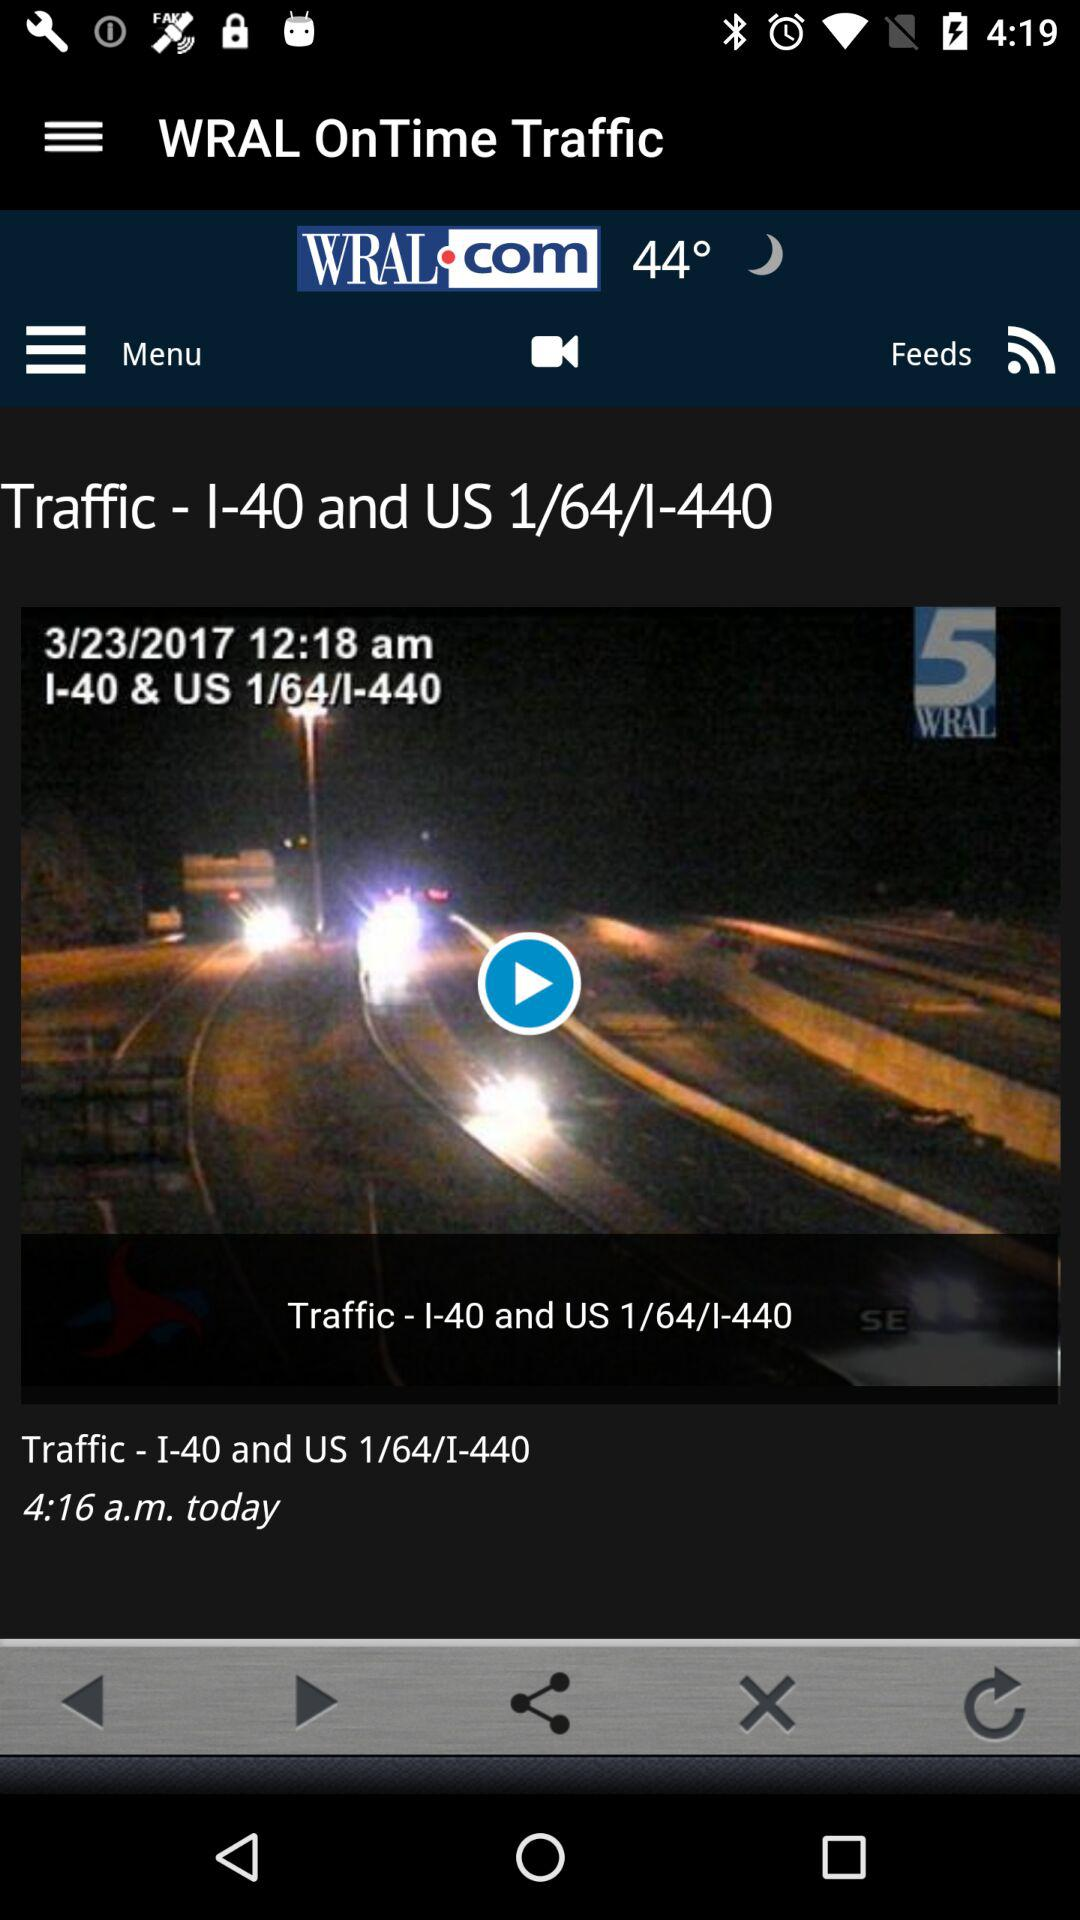What is the name of the television station that is broadcasting the video? The name of the television station that is broadcasting the video is "5WRAL". 